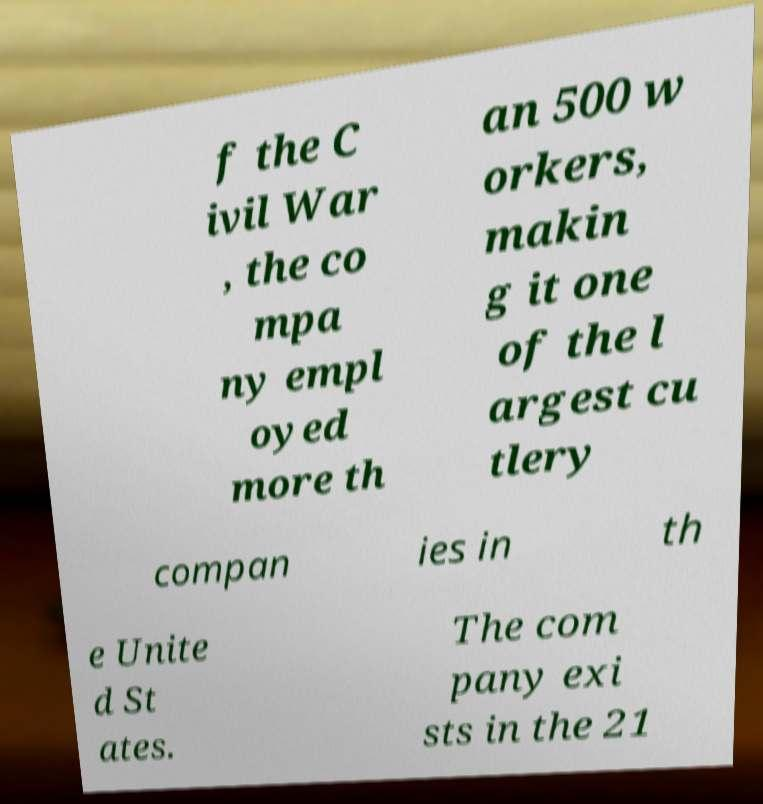Please read and relay the text visible in this image. What does it say? f the C ivil War , the co mpa ny empl oyed more th an 500 w orkers, makin g it one of the l argest cu tlery compan ies in th e Unite d St ates. The com pany exi sts in the 21 